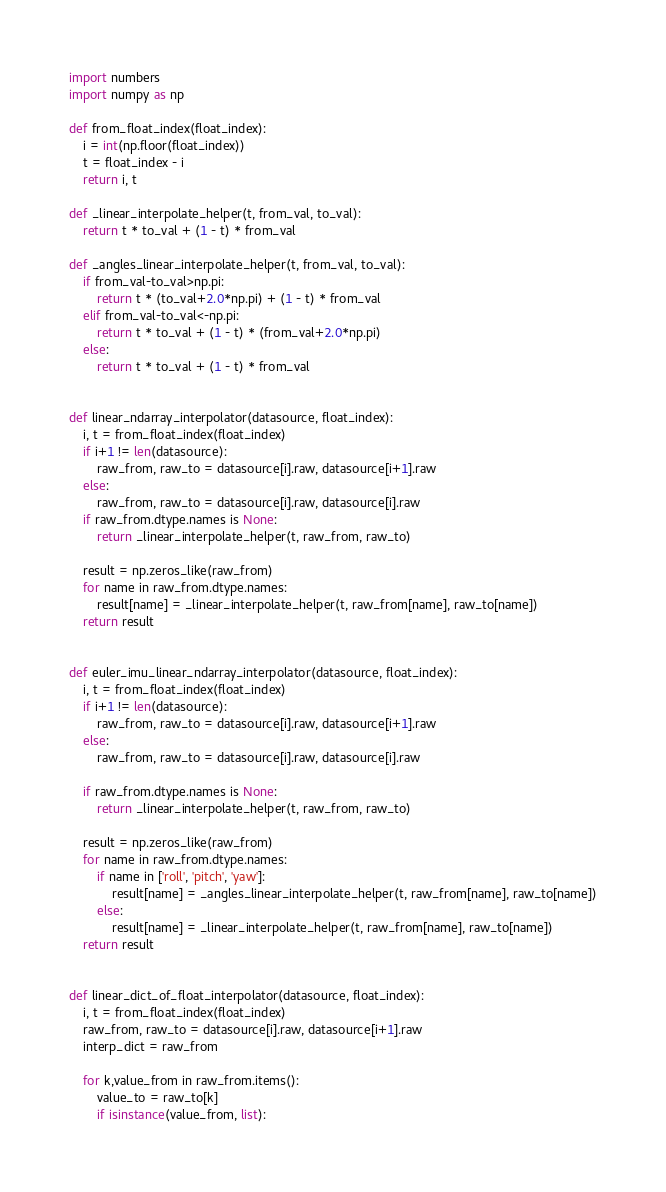Convert code to text. <code><loc_0><loc_0><loc_500><loc_500><_Python_>import numbers
import numpy as np

def from_float_index(float_index):
    i = int(np.floor(float_index))
    t = float_index - i
    return i, t

def _linear_interpolate_helper(t, from_val, to_val):
    return t * to_val + (1 - t) * from_val

def _angles_linear_interpolate_helper(t, from_val, to_val):
    if from_val-to_val>np.pi:
        return t * (to_val+2.0*np.pi) + (1 - t) * from_val
    elif from_val-to_val<-np.pi:
        return t * to_val + (1 - t) * (from_val+2.0*np.pi)
    else:
        return t * to_val + (1 - t) * from_val


def linear_ndarray_interpolator(datasource, float_index):
    i, t = from_float_index(float_index)
    if i+1 != len(datasource):
        raw_from, raw_to = datasource[i].raw, datasource[i+1].raw
    else:
        raw_from, raw_to = datasource[i].raw, datasource[i].raw
    if raw_from.dtype.names is None:
        return _linear_interpolate_helper(t, raw_from, raw_to)
    
    result = np.zeros_like(raw_from)
    for name in raw_from.dtype.names:
        result[name] = _linear_interpolate_helper(t, raw_from[name], raw_to[name])
    return result


def euler_imu_linear_ndarray_interpolator(datasource, float_index):
    i, t = from_float_index(float_index)
    if i+1 != len(datasource):
        raw_from, raw_to = datasource[i].raw, datasource[i+1].raw
    else:
        raw_from, raw_to = datasource[i].raw, datasource[i].raw

    if raw_from.dtype.names is None:
        return _linear_interpolate_helper(t, raw_from, raw_to)
    
    result = np.zeros_like(raw_from)
    for name in raw_from.dtype.names:
        if name in ['roll', 'pitch', 'yaw']:
            result[name] = _angles_linear_interpolate_helper(t, raw_from[name], raw_to[name])
        else:
            result[name] = _linear_interpolate_helper(t, raw_from[name], raw_to[name])
    return result


def linear_dict_of_float_interpolator(datasource, float_index):
    i, t = from_float_index(float_index)
    raw_from, raw_to = datasource[i].raw, datasource[i+1].raw
    interp_dict = raw_from

    for k,value_from in raw_from.items():
        value_to = raw_to[k]
        if isinstance(value_from, list):</code> 